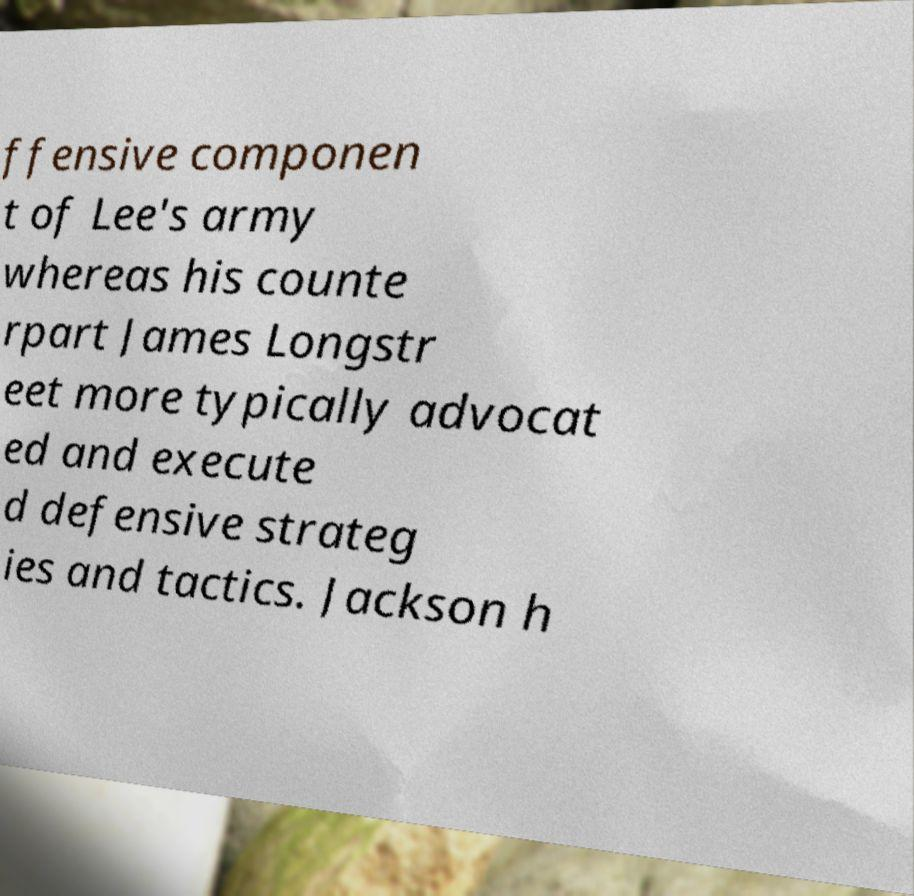Can you read and provide the text displayed in the image?This photo seems to have some interesting text. Can you extract and type it out for me? ffensive componen t of Lee's army whereas his counte rpart James Longstr eet more typically advocat ed and execute d defensive strateg ies and tactics. Jackson h 